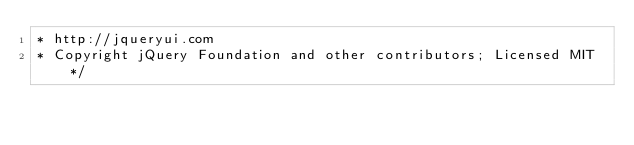<code> <loc_0><loc_0><loc_500><loc_500><_CSS_>* http://jqueryui.com
* Copyright jQuery Foundation and other contributors; Licensed MIT */
</code> 